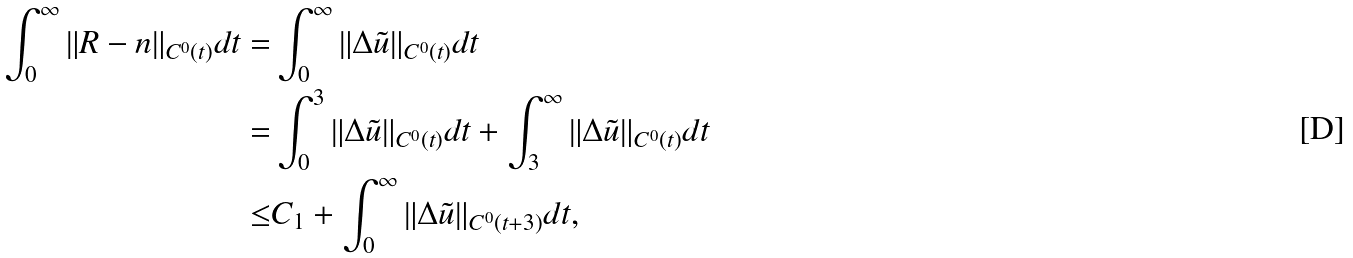<formula> <loc_0><loc_0><loc_500><loc_500>\int _ { 0 } ^ { \infty } \| R - n \| _ { C ^ { 0 } ( t ) } d t = & \int _ { 0 } ^ { \infty } \| \Delta \tilde { u } \| _ { C ^ { 0 } ( t ) } d t \\ = & \int _ { 0 } ^ { 3 } \| \Delta \tilde { u } \| _ { C ^ { 0 } ( t ) } d t + \int _ { 3 } ^ { \infty } \| \Delta \tilde { u } \| _ { C ^ { 0 } ( t ) } d t \\ \leq & C _ { 1 } + \int _ { 0 } ^ { \infty } \| \Delta \tilde { u } \| _ { C ^ { 0 } ( t + 3 ) } d t ,</formula> 